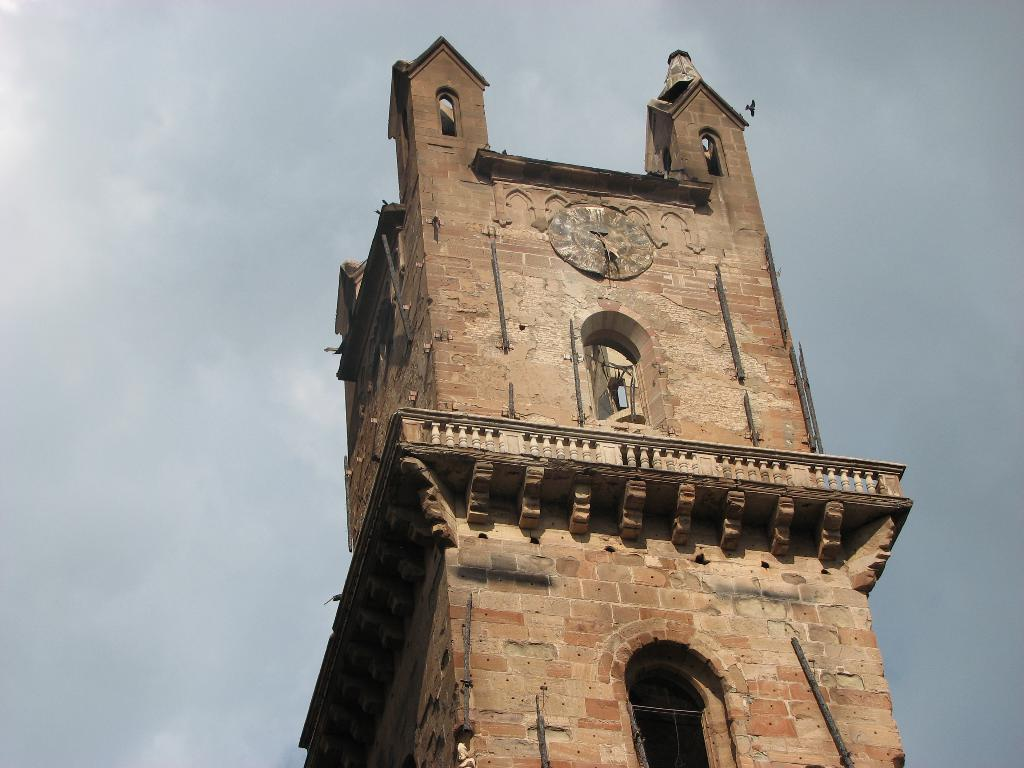What is the main subject of the image? The main subject of the image is a clock tower. Where is the clock tower located in the image? The clock tower is in the middle of the image. What can be seen in the background of the image? The sky is visible in the background of the image. What type of parent is depicted in the image? There is no parent depicted in the image; it features a clock tower. What structure is shown supporting the clock tower in the image? The image does not show any specific structure supporting the clock tower; it only shows the clock tower itself. 